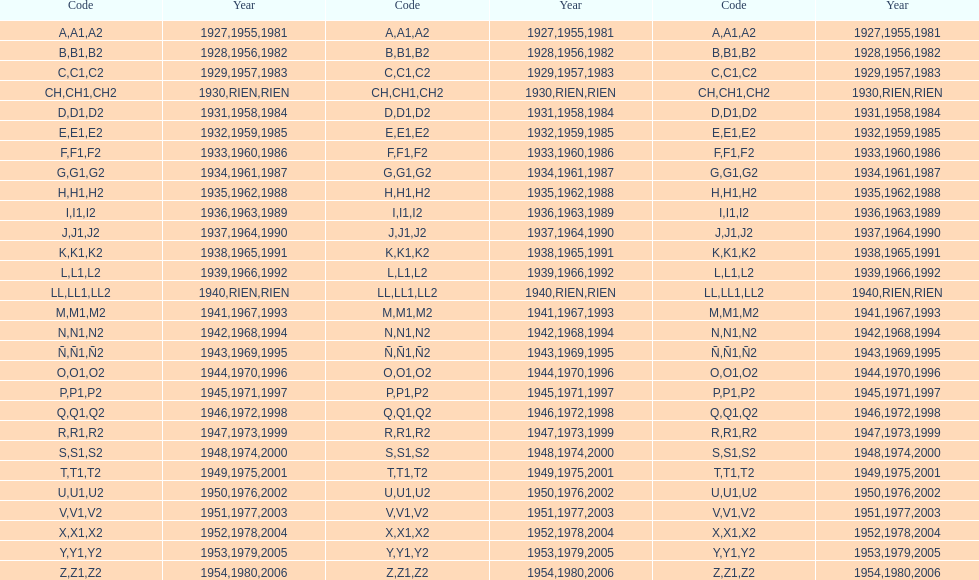Is the e code less than 1950? Yes. 